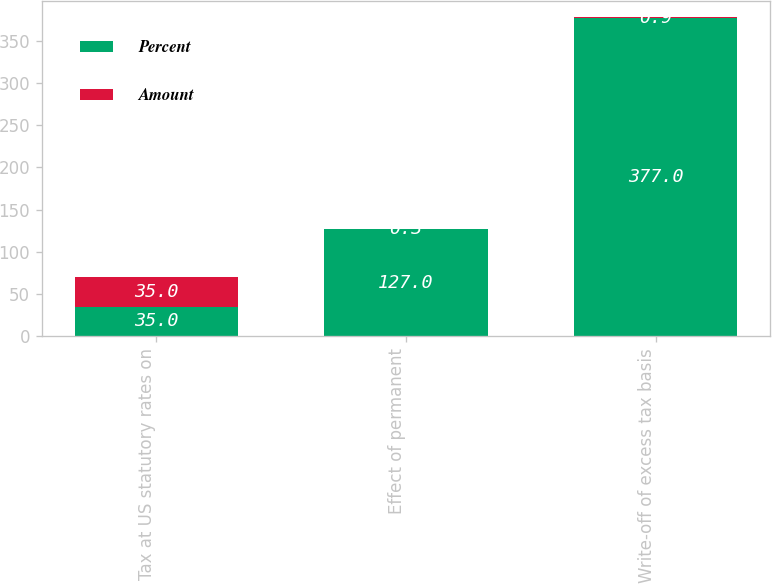<chart> <loc_0><loc_0><loc_500><loc_500><stacked_bar_chart><ecel><fcel>Tax at US statutory rates on<fcel>Effect of permanent<fcel>Write-off of excess tax basis<nl><fcel>Percent<fcel>35<fcel>127<fcel>377<nl><fcel>Amount<fcel>35<fcel>0.3<fcel>0.9<nl></chart> 